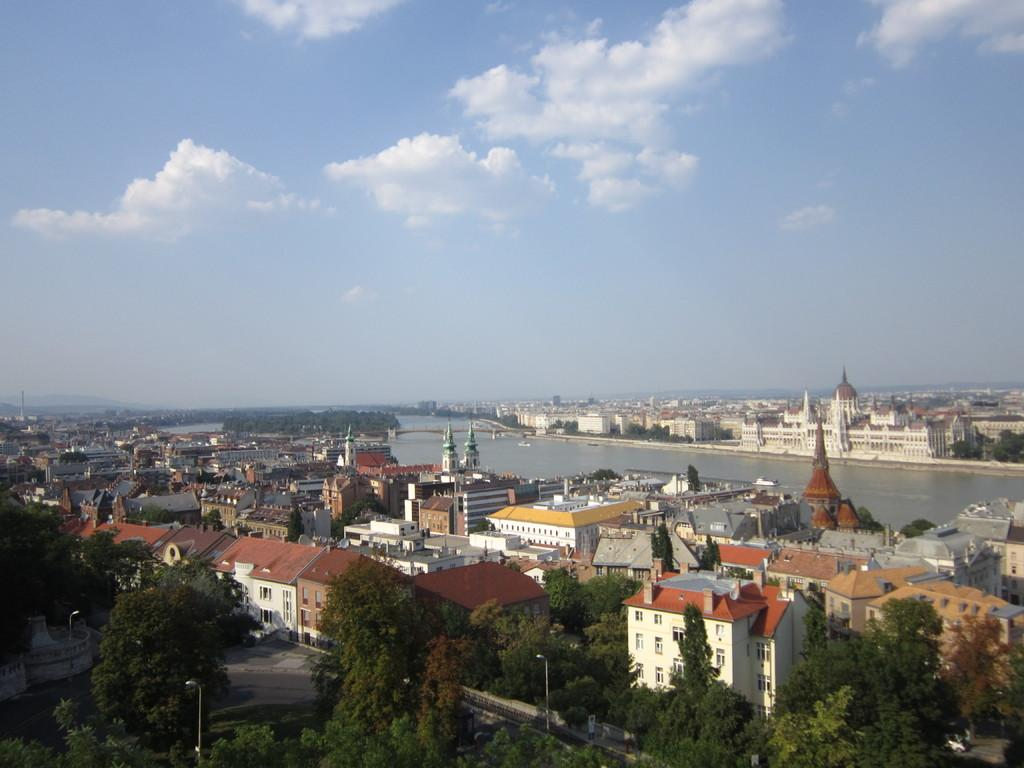What structures are present in the image? There are poles, lights, roads, buildings, a bridge, and trees in the image. What type of surface can be seen in the image? There are roads visible in the image. What natural element is present in the image? There are trees in the image. What is visible in the sky in the image? The sky is visible in the image. What body of water can be seen in the image? There is water visible in the image. What does the mom say about her desire for the brain in the image? There is no mom, brain, or mention of desire in the image. 